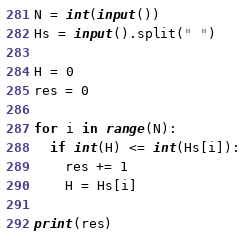<code> <loc_0><loc_0><loc_500><loc_500><_Python_>N = int(input())
Hs = input().split(" ")

H = 0
res = 0

for i in range(N):
  if int(H) <= int(Hs[i]):
    res += 1
    H = Hs[i]

print(res)</code> 